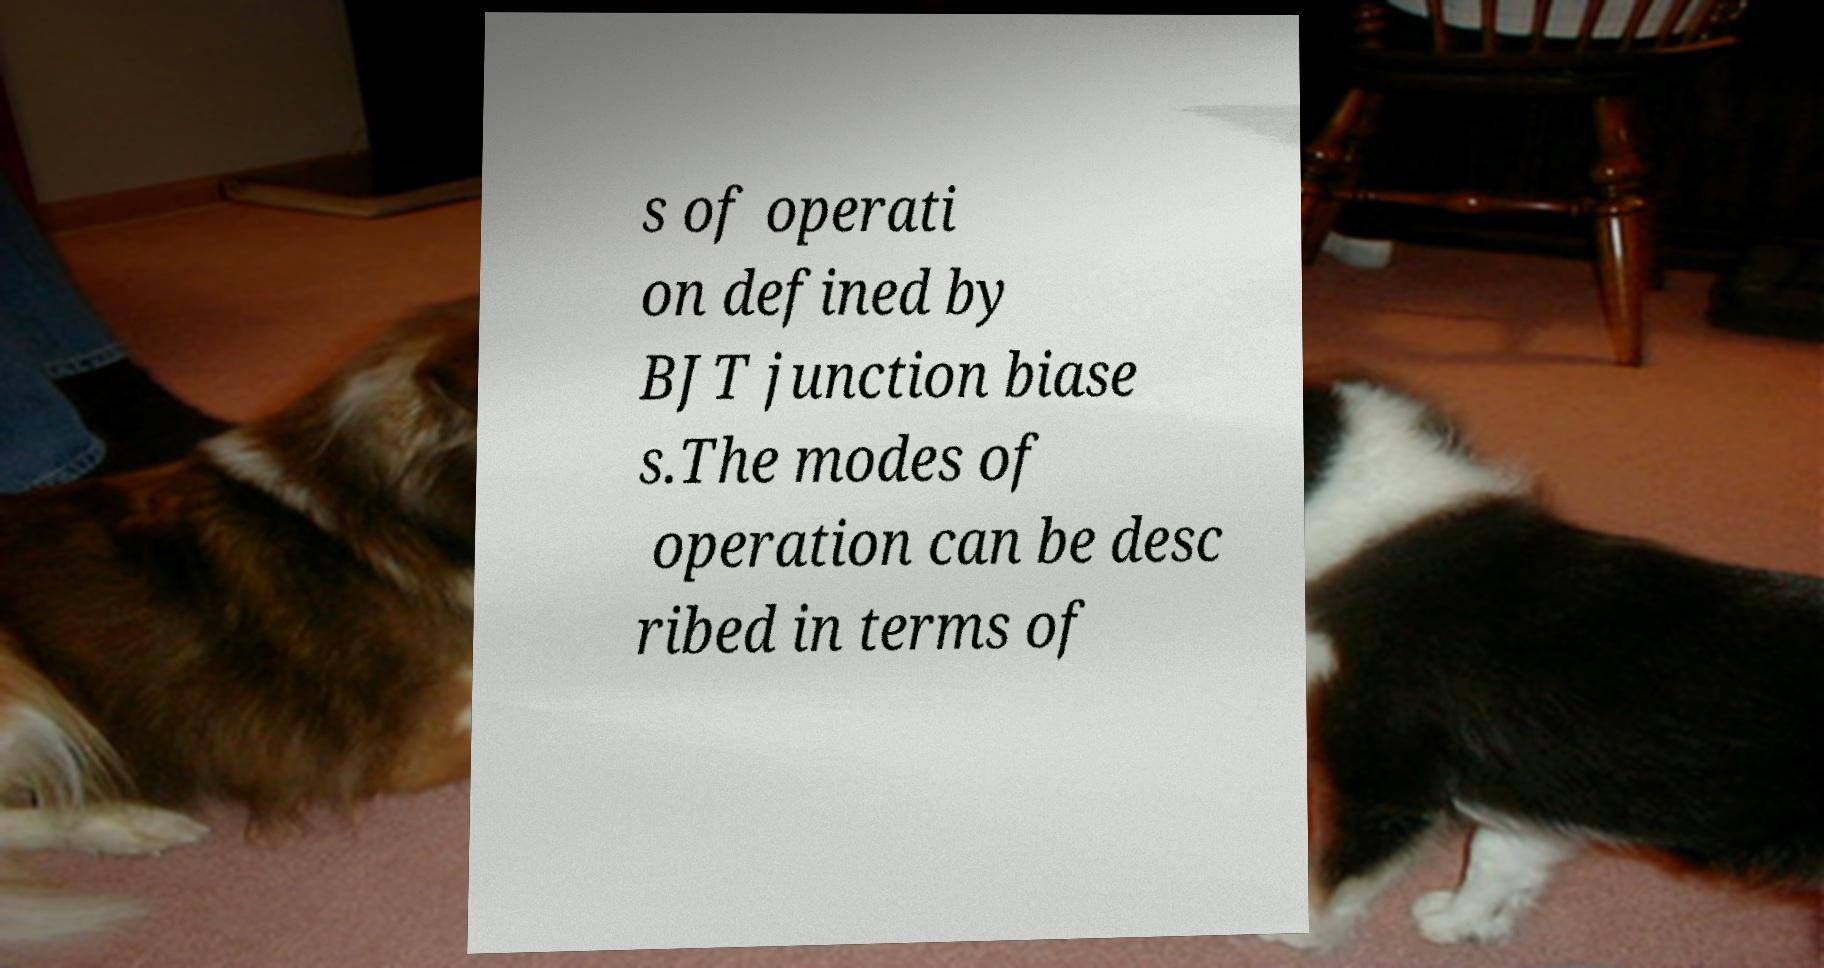Could you assist in decoding the text presented in this image and type it out clearly? s of operati on defined by BJT junction biase s.The modes of operation can be desc ribed in terms of 